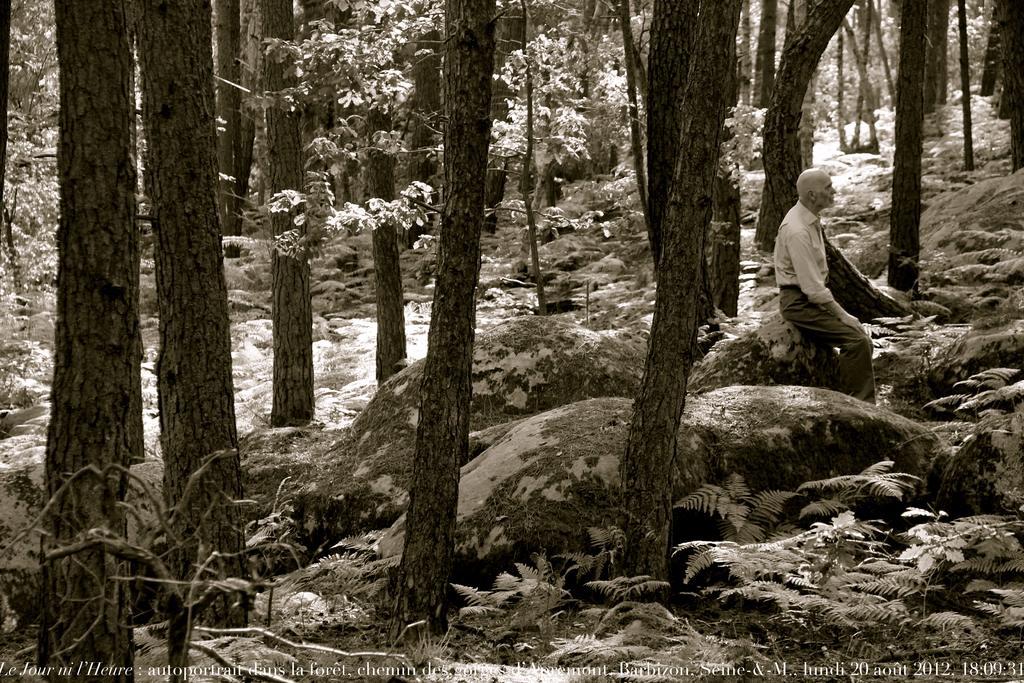Describe this image in one or two sentences. The image is looking like an edited image. The picture is clicked in woods. At the bottom there is text. In this image we can see plants, trees, rocks and a person sitting on the rock. 